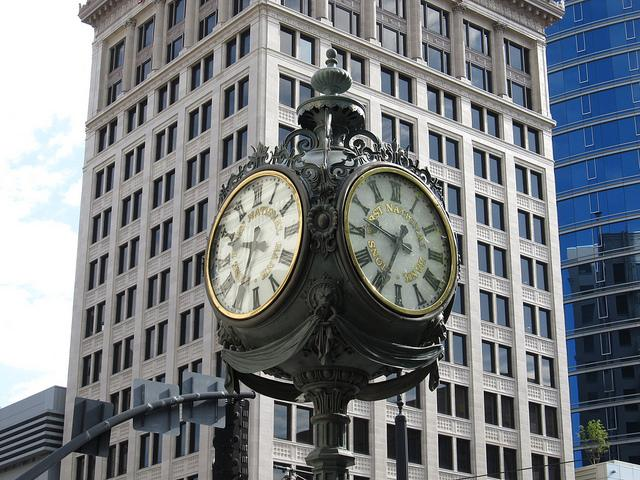What types of buildings are these?

Choices:
A) mobile
B) high rise
C) historical
D) religious high rise 